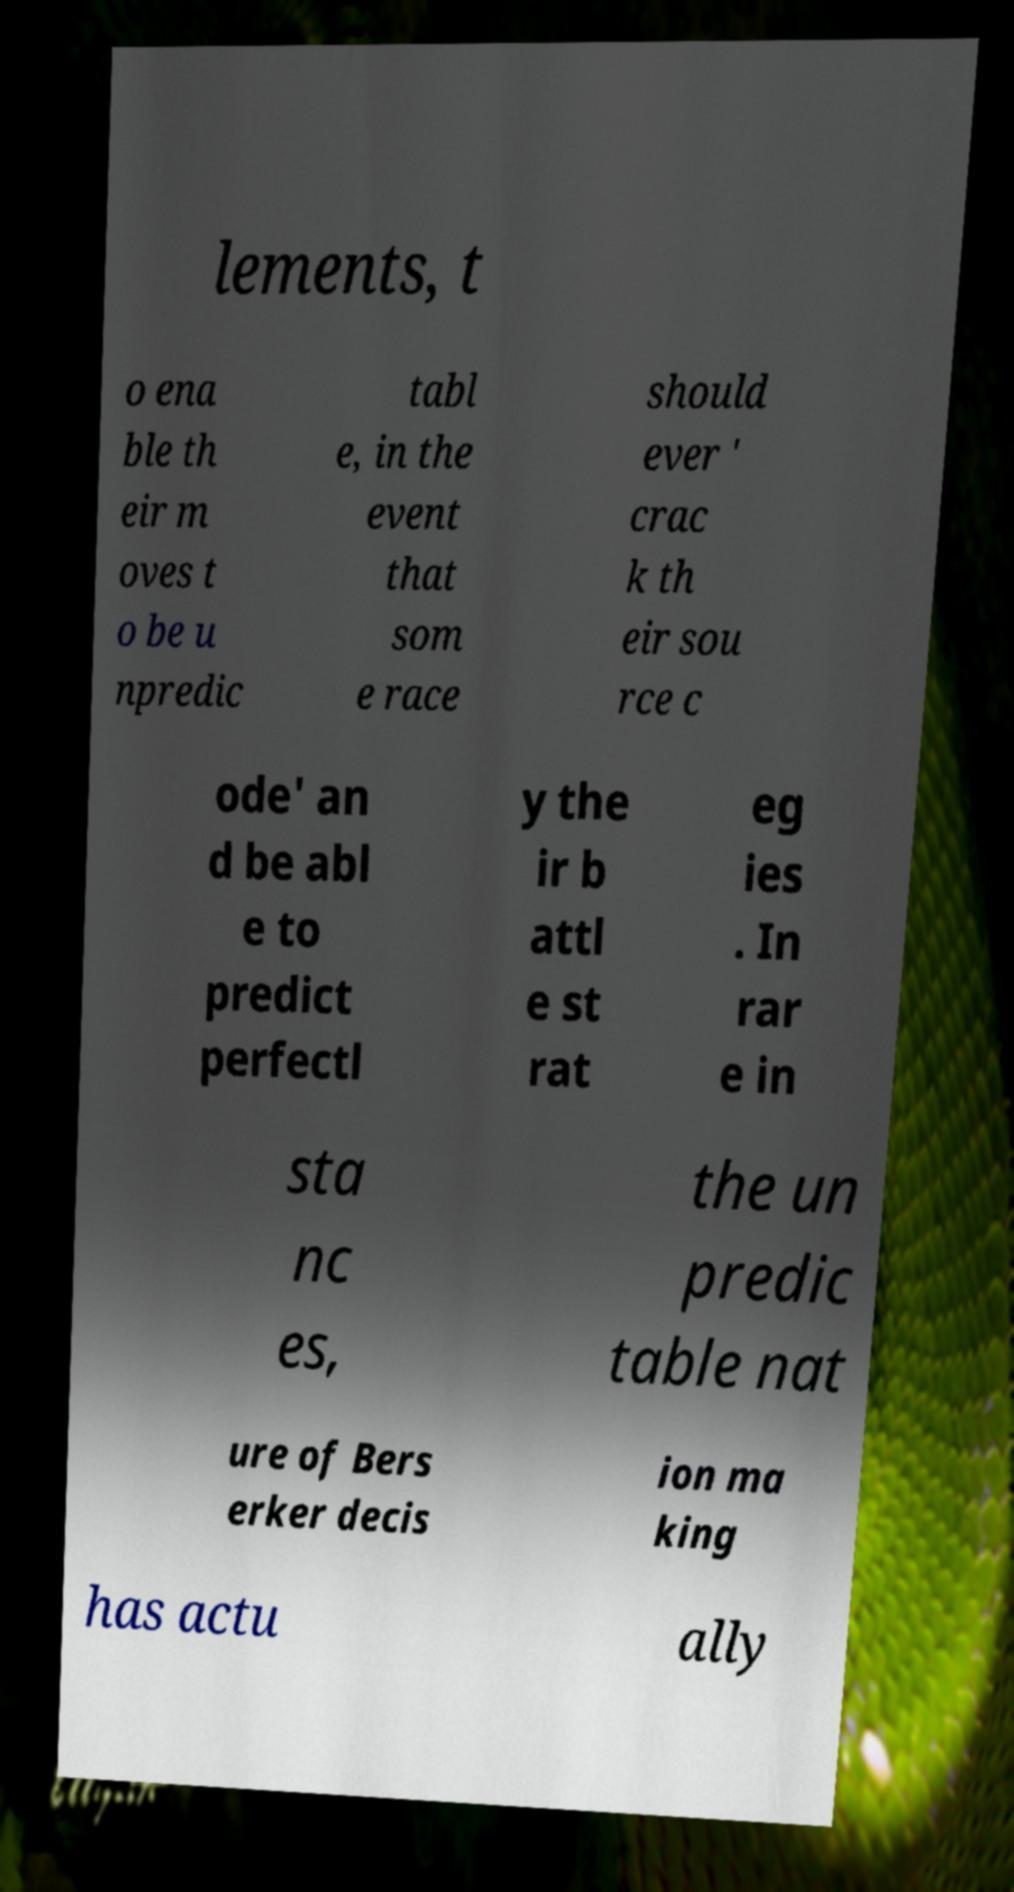I need the written content from this picture converted into text. Can you do that? lements, t o ena ble th eir m oves t o be u npredic tabl e, in the event that som e race should ever ' crac k th eir sou rce c ode' an d be abl e to predict perfectl y the ir b attl e st rat eg ies . In rar e in sta nc es, the un predic table nat ure of Bers erker decis ion ma king has actu ally 